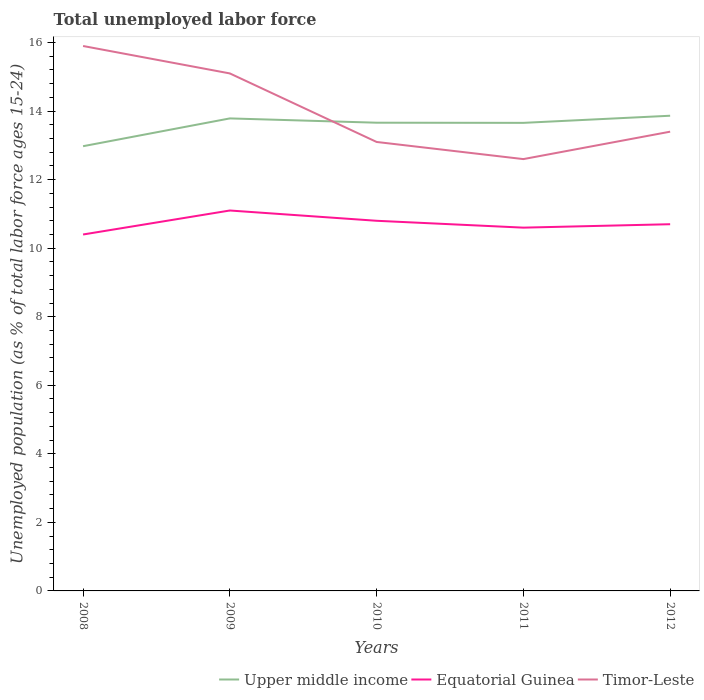Is the number of lines equal to the number of legend labels?
Give a very brief answer. Yes. Across all years, what is the maximum percentage of unemployed population in in Timor-Leste?
Provide a succinct answer. 12.6. In which year was the percentage of unemployed population in in Upper middle income maximum?
Provide a short and direct response. 2008. What is the total percentage of unemployed population in in Upper middle income in the graph?
Ensure brevity in your answer.  -0.08. What is the difference between the highest and the second highest percentage of unemployed population in in Timor-Leste?
Make the answer very short. 3.3. How many lines are there?
Your answer should be compact. 3. How many years are there in the graph?
Make the answer very short. 5. Does the graph contain any zero values?
Your answer should be compact. No. Where does the legend appear in the graph?
Your response must be concise. Bottom right. How many legend labels are there?
Offer a terse response. 3. How are the legend labels stacked?
Give a very brief answer. Horizontal. What is the title of the graph?
Your response must be concise. Total unemployed labor force. Does "Iraq" appear as one of the legend labels in the graph?
Offer a very short reply. No. What is the label or title of the Y-axis?
Offer a terse response. Unemployed population (as % of total labor force ages 15-24). What is the Unemployed population (as % of total labor force ages 15-24) of Upper middle income in 2008?
Provide a succinct answer. 12.98. What is the Unemployed population (as % of total labor force ages 15-24) in Equatorial Guinea in 2008?
Ensure brevity in your answer.  10.4. What is the Unemployed population (as % of total labor force ages 15-24) of Timor-Leste in 2008?
Keep it short and to the point. 15.9. What is the Unemployed population (as % of total labor force ages 15-24) in Upper middle income in 2009?
Make the answer very short. 13.79. What is the Unemployed population (as % of total labor force ages 15-24) in Equatorial Guinea in 2009?
Offer a terse response. 11.1. What is the Unemployed population (as % of total labor force ages 15-24) in Timor-Leste in 2009?
Provide a succinct answer. 15.1. What is the Unemployed population (as % of total labor force ages 15-24) in Upper middle income in 2010?
Provide a succinct answer. 13.66. What is the Unemployed population (as % of total labor force ages 15-24) of Equatorial Guinea in 2010?
Give a very brief answer. 10.8. What is the Unemployed population (as % of total labor force ages 15-24) in Timor-Leste in 2010?
Provide a short and direct response. 13.1. What is the Unemployed population (as % of total labor force ages 15-24) in Upper middle income in 2011?
Ensure brevity in your answer.  13.66. What is the Unemployed population (as % of total labor force ages 15-24) of Equatorial Guinea in 2011?
Give a very brief answer. 10.6. What is the Unemployed population (as % of total labor force ages 15-24) in Timor-Leste in 2011?
Ensure brevity in your answer.  12.6. What is the Unemployed population (as % of total labor force ages 15-24) of Upper middle income in 2012?
Offer a very short reply. 13.87. What is the Unemployed population (as % of total labor force ages 15-24) in Equatorial Guinea in 2012?
Offer a very short reply. 10.7. What is the Unemployed population (as % of total labor force ages 15-24) in Timor-Leste in 2012?
Keep it short and to the point. 13.4. Across all years, what is the maximum Unemployed population (as % of total labor force ages 15-24) in Upper middle income?
Keep it short and to the point. 13.87. Across all years, what is the maximum Unemployed population (as % of total labor force ages 15-24) of Equatorial Guinea?
Offer a terse response. 11.1. Across all years, what is the maximum Unemployed population (as % of total labor force ages 15-24) of Timor-Leste?
Ensure brevity in your answer.  15.9. Across all years, what is the minimum Unemployed population (as % of total labor force ages 15-24) in Upper middle income?
Ensure brevity in your answer.  12.98. Across all years, what is the minimum Unemployed population (as % of total labor force ages 15-24) of Equatorial Guinea?
Your answer should be very brief. 10.4. Across all years, what is the minimum Unemployed population (as % of total labor force ages 15-24) of Timor-Leste?
Give a very brief answer. 12.6. What is the total Unemployed population (as % of total labor force ages 15-24) in Upper middle income in the graph?
Keep it short and to the point. 67.95. What is the total Unemployed population (as % of total labor force ages 15-24) in Equatorial Guinea in the graph?
Ensure brevity in your answer.  53.6. What is the total Unemployed population (as % of total labor force ages 15-24) in Timor-Leste in the graph?
Provide a succinct answer. 70.1. What is the difference between the Unemployed population (as % of total labor force ages 15-24) of Upper middle income in 2008 and that in 2009?
Your response must be concise. -0.81. What is the difference between the Unemployed population (as % of total labor force ages 15-24) in Equatorial Guinea in 2008 and that in 2009?
Your answer should be very brief. -0.7. What is the difference between the Unemployed population (as % of total labor force ages 15-24) in Upper middle income in 2008 and that in 2010?
Offer a terse response. -0.69. What is the difference between the Unemployed population (as % of total labor force ages 15-24) of Equatorial Guinea in 2008 and that in 2010?
Give a very brief answer. -0.4. What is the difference between the Unemployed population (as % of total labor force ages 15-24) of Timor-Leste in 2008 and that in 2010?
Your answer should be compact. 2.8. What is the difference between the Unemployed population (as % of total labor force ages 15-24) in Upper middle income in 2008 and that in 2011?
Your answer should be compact. -0.68. What is the difference between the Unemployed population (as % of total labor force ages 15-24) of Equatorial Guinea in 2008 and that in 2011?
Provide a short and direct response. -0.2. What is the difference between the Unemployed population (as % of total labor force ages 15-24) of Upper middle income in 2008 and that in 2012?
Your response must be concise. -0.89. What is the difference between the Unemployed population (as % of total labor force ages 15-24) of Equatorial Guinea in 2008 and that in 2012?
Offer a very short reply. -0.3. What is the difference between the Unemployed population (as % of total labor force ages 15-24) of Upper middle income in 2009 and that in 2010?
Your response must be concise. 0.13. What is the difference between the Unemployed population (as % of total labor force ages 15-24) in Equatorial Guinea in 2009 and that in 2010?
Provide a short and direct response. 0.3. What is the difference between the Unemployed population (as % of total labor force ages 15-24) of Upper middle income in 2009 and that in 2011?
Provide a short and direct response. 0.13. What is the difference between the Unemployed population (as % of total labor force ages 15-24) of Upper middle income in 2009 and that in 2012?
Your answer should be very brief. -0.08. What is the difference between the Unemployed population (as % of total labor force ages 15-24) of Upper middle income in 2010 and that in 2011?
Offer a very short reply. 0. What is the difference between the Unemployed population (as % of total labor force ages 15-24) of Equatorial Guinea in 2010 and that in 2011?
Make the answer very short. 0.2. What is the difference between the Unemployed population (as % of total labor force ages 15-24) in Timor-Leste in 2010 and that in 2011?
Offer a very short reply. 0.5. What is the difference between the Unemployed population (as % of total labor force ages 15-24) in Upper middle income in 2010 and that in 2012?
Provide a succinct answer. -0.2. What is the difference between the Unemployed population (as % of total labor force ages 15-24) in Timor-Leste in 2010 and that in 2012?
Give a very brief answer. -0.3. What is the difference between the Unemployed population (as % of total labor force ages 15-24) in Upper middle income in 2011 and that in 2012?
Provide a succinct answer. -0.21. What is the difference between the Unemployed population (as % of total labor force ages 15-24) of Upper middle income in 2008 and the Unemployed population (as % of total labor force ages 15-24) of Equatorial Guinea in 2009?
Provide a succinct answer. 1.88. What is the difference between the Unemployed population (as % of total labor force ages 15-24) of Upper middle income in 2008 and the Unemployed population (as % of total labor force ages 15-24) of Timor-Leste in 2009?
Give a very brief answer. -2.12. What is the difference between the Unemployed population (as % of total labor force ages 15-24) in Equatorial Guinea in 2008 and the Unemployed population (as % of total labor force ages 15-24) in Timor-Leste in 2009?
Make the answer very short. -4.7. What is the difference between the Unemployed population (as % of total labor force ages 15-24) of Upper middle income in 2008 and the Unemployed population (as % of total labor force ages 15-24) of Equatorial Guinea in 2010?
Your answer should be compact. 2.18. What is the difference between the Unemployed population (as % of total labor force ages 15-24) of Upper middle income in 2008 and the Unemployed population (as % of total labor force ages 15-24) of Timor-Leste in 2010?
Give a very brief answer. -0.12. What is the difference between the Unemployed population (as % of total labor force ages 15-24) of Upper middle income in 2008 and the Unemployed population (as % of total labor force ages 15-24) of Equatorial Guinea in 2011?
Ensure brevity in your answer.  2.38. What is the difference between the Unemployed population (as % of total labor force ages 15-24) in Upper middle income in 2008 and the Unemployed population (as % of total labor force ages 15-24) in Timor-Leste in 2011?
Your answer should be compact. 0.38. What is the difference between the Unemployed population (as % of total labor force ages 15-24) of Upper middle income in 2008 and the Unemployed population (as % of total labor force ages 15-24) of Equatorial Guinea in 2012?
Keep it short and to the point. 2.28. What is the difference between the Unemployed population (as % of total labor force ages 15-24) in Upper middle income in 2008 and the Unemployed population (as % of total labor force ages 15-24) in Timor-Leste in 2012?
Provide a succinct answer. -0.42. What is the difference between the Unemployed population (as % of total labor force ages 15-24) in Upper middle income in 2009 and the Unemployed population (as % of total labor force ages 15-24) in Equatorial Guinea in 2010?
Offer a very short reply. 2.99. What is the difference between the Unemployed population (as % of total labor force ages 15-24) in Upper middle income in 2009 and the Unemployed population (as % of total labor force ages 15-24) in Timor-Leste in 2010?
Ensure brevity in your answer.  0.69. What is the difference between the Unemployed population (as % of total labor force ages 15-24) in Upper middle income in 2009 and the Unemployed population (as % of total labor force ages 15-24) in Equatorial Guinea in 2011?
Your answer should be very brief. 3.19. What is the difference between the Unemployed population (as % of total labor force ages 15-24) of Upper middle income in 2009 and the Unemployed population (as % of total labor force ages 15-24) of Timor-Leste in 2011?
Provide a short and direct response. 1.19. What is the difference between the Unemployed population (as % of total labor force ages 15-24) of Equatorial Guinea in 2009 and the Unemployed population (as % of total labor force ages 15-24) of Timor-Leste in 2011?
Keep it short and to the point. -1.5. What is the difference between the Unemployed population (as % of total labor force ages 15-24) of Upper middle income in 2009 and the Unemployed population (as % of total labor force ages 15-24) of Equatorial Guinea in 2012?
Make the answer very short. 3.09. What is the difference between the Unemployed population (as % of total labor force ages 15-24) in Upper middle income in 2009 and the Unemployed population (as % of total labor force ages 15-24) in Timor-Leste in 2012?
Your answer should be compact. 0.39. What is the difference between the Unemployed population (as % of total labor force ages 15-24) of Upper middle income in 2010 and the Unemployed population (as % of total labor force ages 15-24) of Equatorial Guinea in 2011?
Your answer should be very brief. 3.06. What is the difference between the Unemployed population (as % of total labor force ages 15-24) in Upper middle income in 2010 and the Unemployed population (as % of total labor force ages 15-24) in Timor-Leste in 2011?
Provide a succinct answer. 1.06. What is the difference between the Unemployed population (as % of total labor force ages 15-24) of Upper middle income in 2010 and the Unemployed population (as % of total labor force ages 15-24) of Equatorial Guinea in 2012?
Offer a very short reply. 2.96. What is the difference between the Unemployed population (as % of total labor force ages 15-24) in Upper middle income in 2010 and the Unemployed population (as % of total labor force ages 15-24) in Timor-Leste in 2012?
Offer a terse response. 0.26. What is the difference between the Unemployed population (as % of total labor force ages 15-24) in Equatorial Guinea in 2010 and the Unemployed population (as % of total labor force ages 15-24) in Timor-Leste in 2012?
Keep it short and to the point. -2.6. What is the difference between the Unemployed population (as % of total labor force ages 15-24) in Upper middle income in 2011 and the Unemployed population (as % of total labor force ages 15-24) in Equatorial Guinea in 2012?
Ensure brevity in your answer.  2.96. What is the difference between the Unemployed population (as % of total labor force ages 15-24) of Upper middle income in 2011 and the Unemployed population (as % of total labor force ages 15-24) of Timor-Leste in 2012?
Offer a very short reply. 0.26. What is the difference between the Unemployed population (as % of total labor force ages 15-24) of Equatorial Guinea in 2011 and the Unemployed population (as % of total labor force ages 15-24) of Timor-Leste in 2012?
Provide a succinct answer. -2.8. What is the average Unemployed population (as % of total labor force ages 15-24) in Upper middle income per year?
Keep it short and to the point. 13.59. What is the average Unemployed population (as % of total labor force ages 15-24) of Equatorial Guinea per year?
Ensure brevity in your answer.  10.72. What is the average Unemployed population (as % of total labor force ages 15-24) of Timor-Leste per year?
Your answer should be compact. 14.02. In the year 2008, what is the difference between the Unemployed population (as % of total labor force ages 15-24) of Upper middle income and Unemployed population (as % of total labor force ages 15-24) of Equatorial Guinea?
Provide a short and direct response. 2.58. In the year 2008, what is the difference between the Unemployed population (as % of total labor force ages 15-24) in Upper middle income and Unemployed population (as % of total labor force ages 15-24) in Timor-Leste?
Ensure brevity in your answer.  -2.92. In the year 2009, what is the difference between the Unemployed population (as % of total labor force ages 15-24) in Upper middle income and Unemployed population (as % of total labor force ages 15-24) in Equatorial Guinea?
Give a very brief answer. 2.69. In the year 2009, what is the difference between the Unemployed population (as % of total labor force ages 15-24) in Upper middle income and Unemployed population (as % of total labor force ages 15-24) in Timor-Leste?
Offer a very short reply. -1.31. In the year 2010, what is the difference between the Unemployed population (as % of total labor force ages 15-24) of Upper middle income and Unemployed population (as % of total labor force ages 15-24) of Equatorial Guinea?
Your answer should be very brief. 2.86. In the year 2010, what is the difference between the Unemployed population (as % of total labor force ages 15-24) of Upper middle income and Unemployed population (as % of total labor force ages 15-24) of Timor-Leste?
Offer a terse response. 0.56. In the year 2011, what is the difference between the Unemployed population (as % of total labor force ages 15-24) of Upper middle income and Unemployed population (as % of total labor force ages 15-24) of Equatorial Guinea?
Provide a short and direct response. 3.06. In the year 2011, what is the difference between the Unemployed population (as % of total labor force ages 15-24) in Upper middle income and Unemployed population (as % of total labor force ages 15-24) in Timor-Leste?
Provide a succinct answer. 1.06. In the year 2012, what is the difference between the Unemployed population (as % of total labor force ages 15-24) of Upper middle income and Unemployed population (as % of total labor force ages 15-24) of Equatorial Guinea?
Provide a succinct answer. 3.17. In the year 2012, what is the difference between the Unemployed population (as % of total labor force ages 15-24) of Upper middle income and Unemployed population (as % of total labor force ages 15-24) of Timor-Leste?
Offer a very short reply. 0.47. In the year 2012, what is the difference between the Unemployed population (as % of total labor force ages 15-24) in Equatorial Guinea and Unemployed population (as % of total labor force ages 15-24) in Timor-Leste?
Keep it short and to the point. -2.7. What is the ratio of the Unemployed population (as % of total labor force ages 15-24) of Upper middle income in 2008 to that in 2009?
Your answer should be compact. 0.94. What is the ratio of the Unemployed population (as % of total labor force ages 15-24) in Equatorial Guinea in 2008 to that in 2009?
Offer a very short reply. 0.94. What is the ratio of the Unemployed population (as % of total labor force ages 15-24) in Timor-Leste in 2008 to that in 2009?
Your answer should be compact. 1.05. What is the ratio of the Unemployed population (as % of total labor force ages 15-24) in Upper middle income in 2008 to that in 2010?
Offer a very short reply. 0.95. What is the ratio of the Unemployed population (as % of total labor force ages 15-24) of Timor-Leste in 2008 to that in 2010?
Provide a short and direct response. 1.21. What is the ratio of the Unemployed population (as % of total labor force ages 15-24) of Upper middle income in 2008 to that in 2011?
Make the answer very short. 0.95. What is the ratio of the Unemployed population (as % of total labor force ages 15-24) in Equatorial Guinea in 2008 to that in 2011?
Provide a short and direct response. 0.98. What is the ratio of the Unemployed population (as % of total labor force ages 15-24) in Timor-Leste in 2008 to that in 2011?
Offer a terse response. 1.26. What is the ratio of the Unemployed population (as % of total labor force ages 15-24) of Upper middle income in 2008 to that in 2012?
Keep it short and to the point. 0.94. What is the ratio of the Unemployed population (as % of total labor force ages 15-24) of Equatorial Guinea in 2008 to that in 2012?
Your response must be concise. 0.97. What is the ratio of the Unemployed population (as % of total labor force ages 15-24) in Timor-Leste in 2008 to that in 2012?
Your answer should be compact. 1.19. What is the ratio of the Unemployed population (as % of total labor force ages 15-24) in Upper middle income in 2009 to that in 2010?
Provide a short and direct response. 1.01. What is the ratio of the Unemployed population (as % of total labor force ages 15-24) of Equatorial Guinea in 2009 to that in 2010?
Provide a short and direct response. 1.03. What is the ratio of the Unemployed population (as % of total labor force ages 15-24) in Timor-Leste in 2009 to that in 2010?
Keep it short and to the point. 1.15. What is the ratio of the Unemployed population (as % of total labor force ages 15-24) of Upper middle income in 2009 to that in 2011?
Make the answer very short. 1.01. What is the ratio of the Unemployed population (as % of total labor force ages 15-24) in Equatorial Guinea in 2009 to that in 2011?
Offer a terse response. 1.05. What is the ratio of the Unemployed population (as % of total labor force ages 15-24) in Timor-Leste in 2009 to that in 2011?
Ensure brevity in your answer.  1.2. What is the ratio of the Unemployed population (as % of total labor force ages 15-24) in Upper middle income in 2009 to that in 2012?
Your response must be concise. 0.99. What is the ratio of the Unemployed population (as % of total labor force ages 15-24) of Equatorial Guinea in 2009 to that in 2012?
Make the answer very short. 1.04. What is the ratio of the Unemployed population (as % of total labor force ages 15-24) of Timor-Leste in 2009 to that in 2012?
Offer a very short reply. 1.13. What is the ratio of the Unemployed population (as % of total labor force ages 15-24) in Upper middle income in 2010 to that in 2011?
Make the answer very short. 1. What is the ratio of the Unemployed population (as % of total labor force ages 15-24) of Equatorial Guinea in 2010 to that in 2011?
Keep it short and to the point. 1.02. What is the ratio of the Unemployed population (as % of total labor force ages 15-24) in Timor-Leste in 2010 to that in 2011?
Offer a very short reply. 1.04. What is the ratio of the Unemployed population (as % of total labor force ages 15-24) of Equatorial Guinea in 2010 to that in 2012?
Provide a succinct answer. 1.01. What is the ratio of the Unemployed population (as % of total labor force ages 15-24) in Timor-Leste in 2010 to that in 2012?
Offer a terse response. 0.98. What is the ratio of the Unemployed population (as % of total labor force ages 15-24) in Upper middle income in 2011 to that in 2012?
Your answer should be compact. 0.98. What is the ratio of the Unemployed population (as % of total labor force ages 15-24) of Timor-Leste in 2011 to that in 2012?
Give a very brief answer. 0.94. What is the difference between the highest and the second highest Unemployed population (as % of total labor force ages 15-24) in Upper middle income?
Your answer should be very brief. 0.08. What is the difference between the highest and the second highest Unemployed population (as % of total labor force ages 15-24) in Equatorial Guinea?
Offer a terse response. 0.3. What is the difference between the highest and the second highest Unemployed population (as % of total labor force ages 15-24) of Timor-Leste?
Make the answer very short. 0.8. What is the difference between the highest and the lowest Unemployed population (as % of total labor force ages 15-24) of Upper middle income?
Provide a short and direct response. 0.89. What is the difference between the highest and the lowest Unemployed population (as % of total labor force ages 15-24) of Equatorial Guinea?
Keep it short and to the point. 0.7. What is the difference between the highest and the lowest Unemployed population (as % of total labor force ages 15-24) of Timor-Leste?
Give a very brief answer. 3.3. 